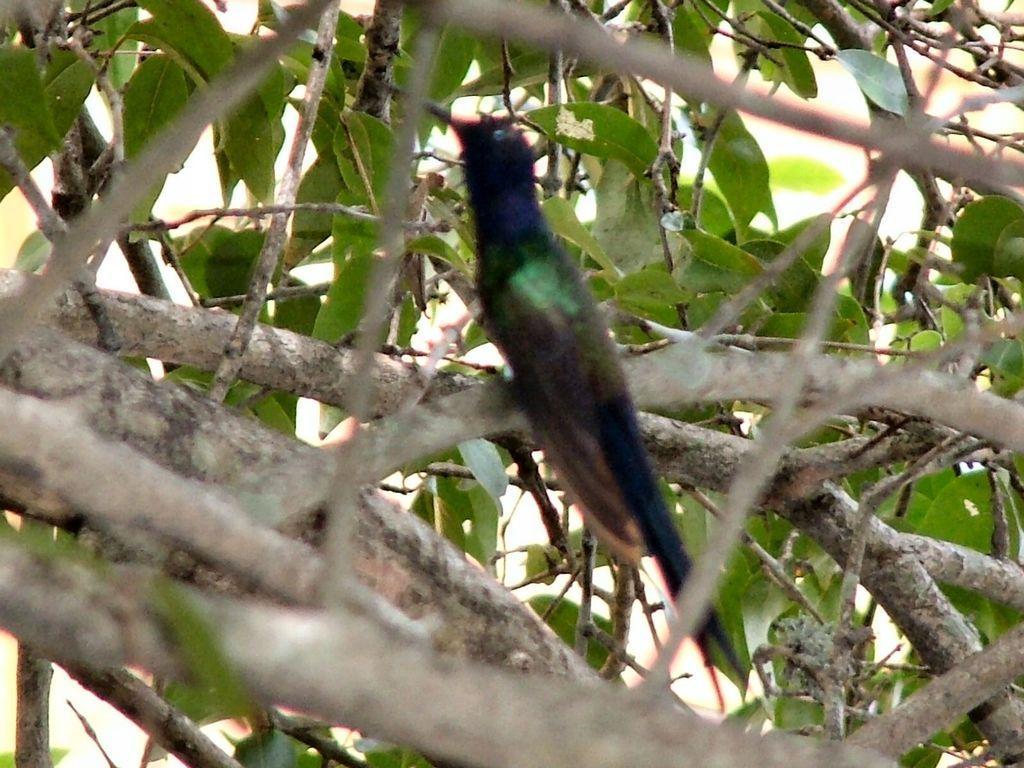How would you summarize this image in a sentence or two? In this image we can see a bird on the branch of a tree. 